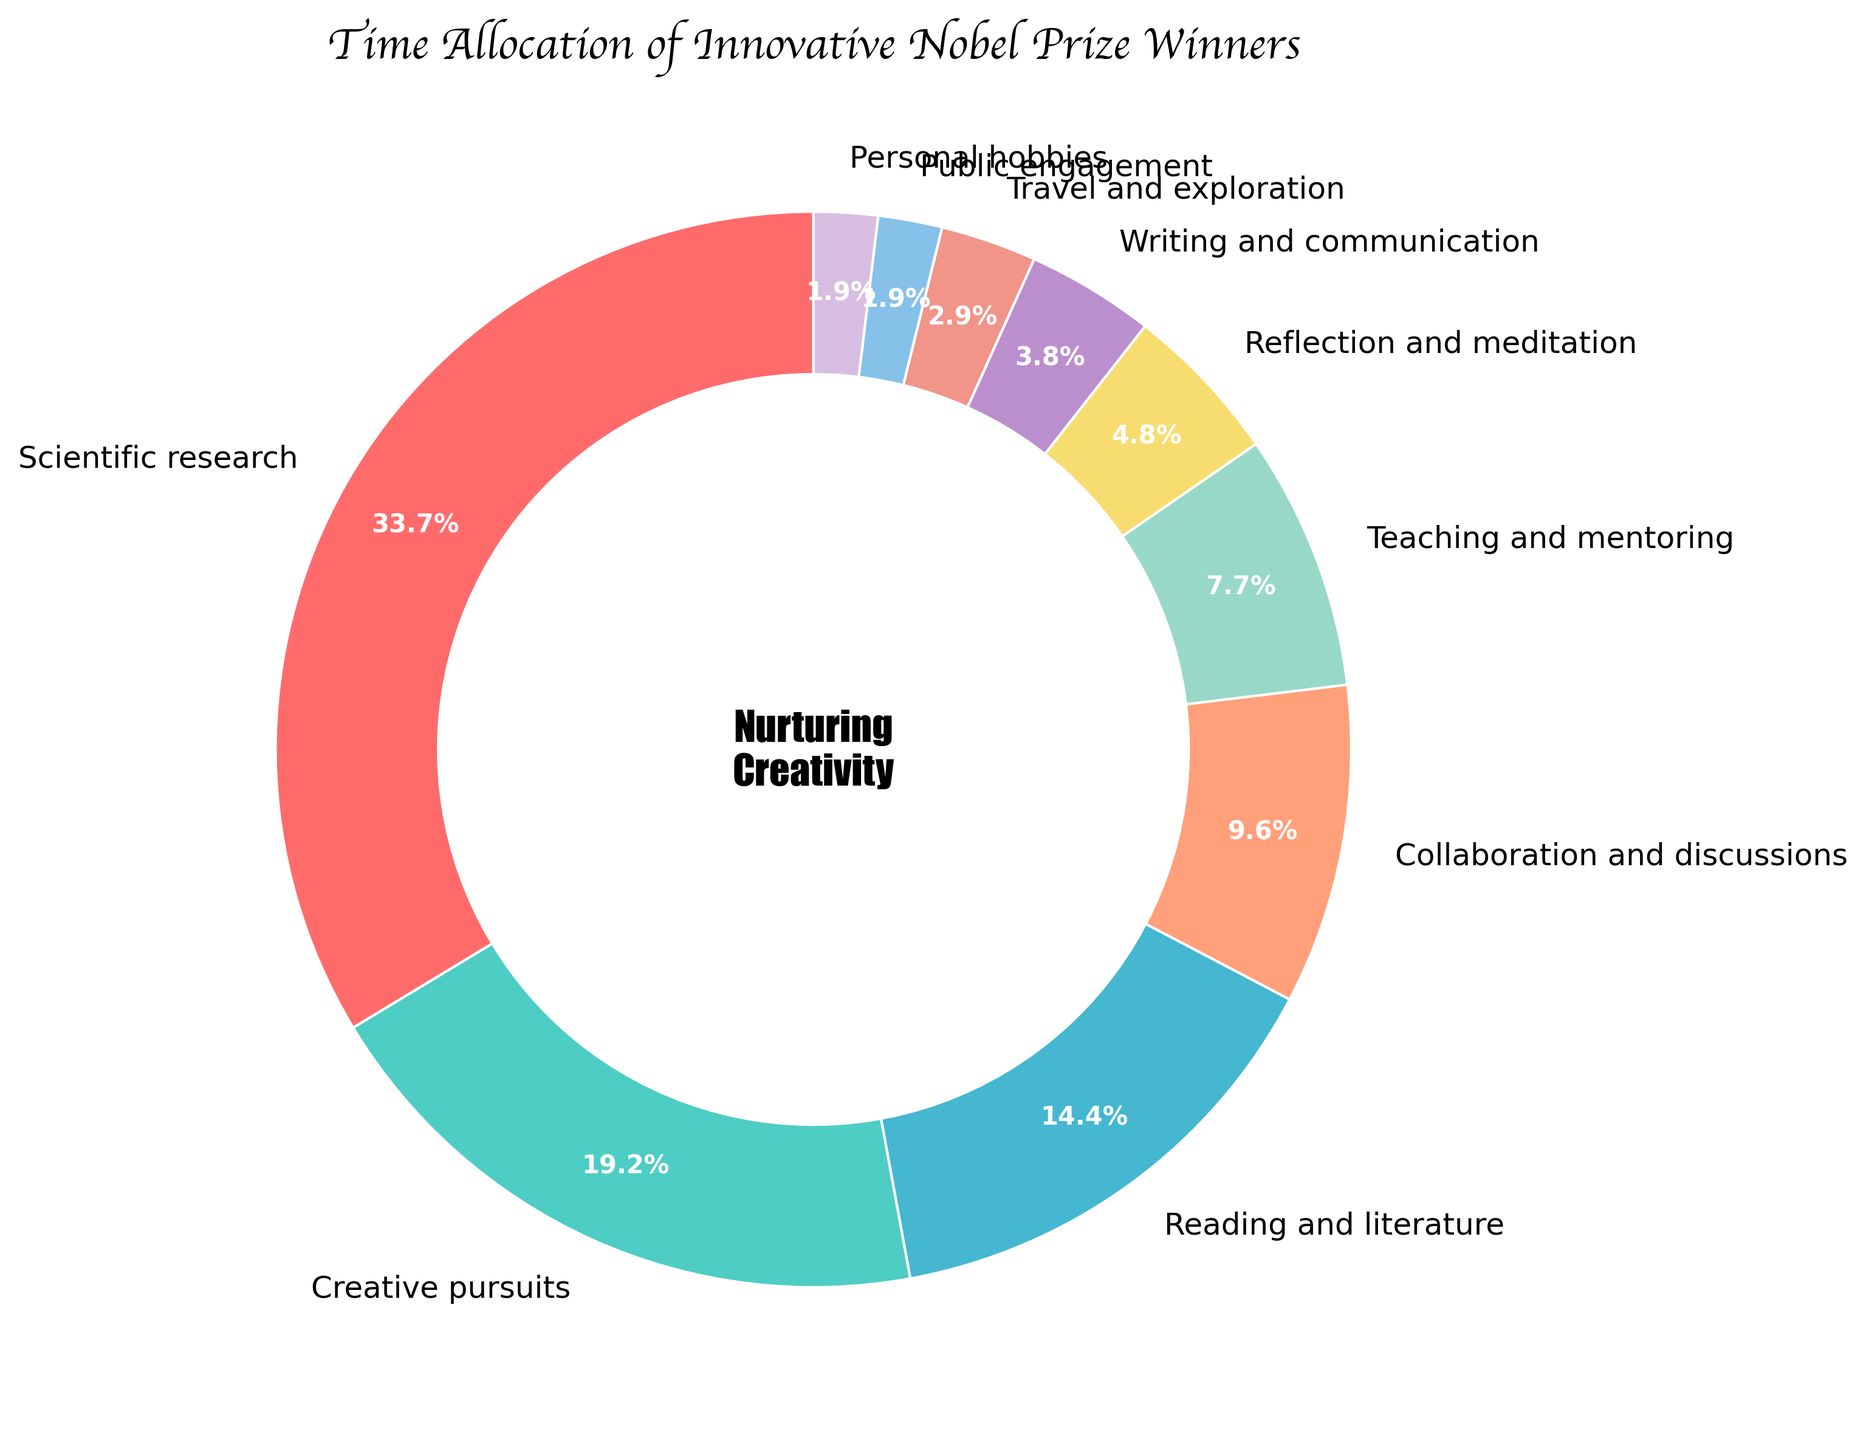What activity takes up the largest percentage of time? Look at the pie chart and identify the activity segment that occupies the largest area. The slice labeled "Scientific research" occupies the largest area at 35%.
Answer: Scientific research How much more time is spent on Creative pursuits compared to Collaboration and discussions? First, find the percentage for Creative pursuits (20%) and Collaboration and discussions (10%). Then, subtract the smaller percentage from the larger one: 20% - 10% = 10%.
Answer: 10% Which activities combined make up exactly 10% of the time? Identify individual slices and their corresponding percentages. The activities "Public engagement" and "Personal hobbies" are each 2%, adding up to 4%. "Writing and communication" is another 4%. Adding all these together gives 4% + 4% + 2% = 10%.
Answer: Public engagement and Personal hobbies and Writing and communication What is the percentage difference between Teaching and mentoring and Reflection and meditation? Find the two relevant segments: Teaching and mentoring (8%) and Reflection and meditation (5%). Subtract the smaller percentage from the larger one: 8% - 5% = 3%.
Answer: 3% Which segment has a higher percentage: Reading and literature or Teaching and mentoring? Compare the slices labeled "Reading and literature" which is 15%, and "Teaching and mentoring" which is 8%. Reading and literature has the higher percentage.
Answer: Reading and literature How much time is allocated to activities related to personal development (Reflection and meditation, Personal hobbies)? Identify the segments for Reflection and meditation (5%) and Personal hobbies (2%). Add these percentages together: 5% + 2% = 7%.
Answer: 7% What color represents the Collaboration and discussions activity? Observe the pie chart and find the segment labeled "Collaboration and discussions". The color is a shade of blue.
Answer: Blue Which activities combined amount to less than 5% of total time? Identify segments with values under 5%. The activities labeled "Writing and communication" (4%), "Travel and exploration" (3%), "Public engagement" (2%), and "Personal hobbies" (2%) all fall under 5%. However, combining them leads to more than 5%. The only activity which is less than 5% alone is "Public engagement" and "Personal hobbies".
Answer: Public engagement and Personal hobbies Are there more activities with a percentage of 5% or less than greater than 5%? Count the segments that are 5% or less: Reflection and meditation (5%), Writing and communication (4%), Travel and exploration (3%), Public engagement (2%), Personal hobbies (2%) = 5 activities. For activities more than 5%: Scientific research (35%), Creative pursuits (20%), Reading and literature (15%), Collaboration and discussions (10%), Teaching and mentoring (8%) = 5 activities.
Answer: Equal 